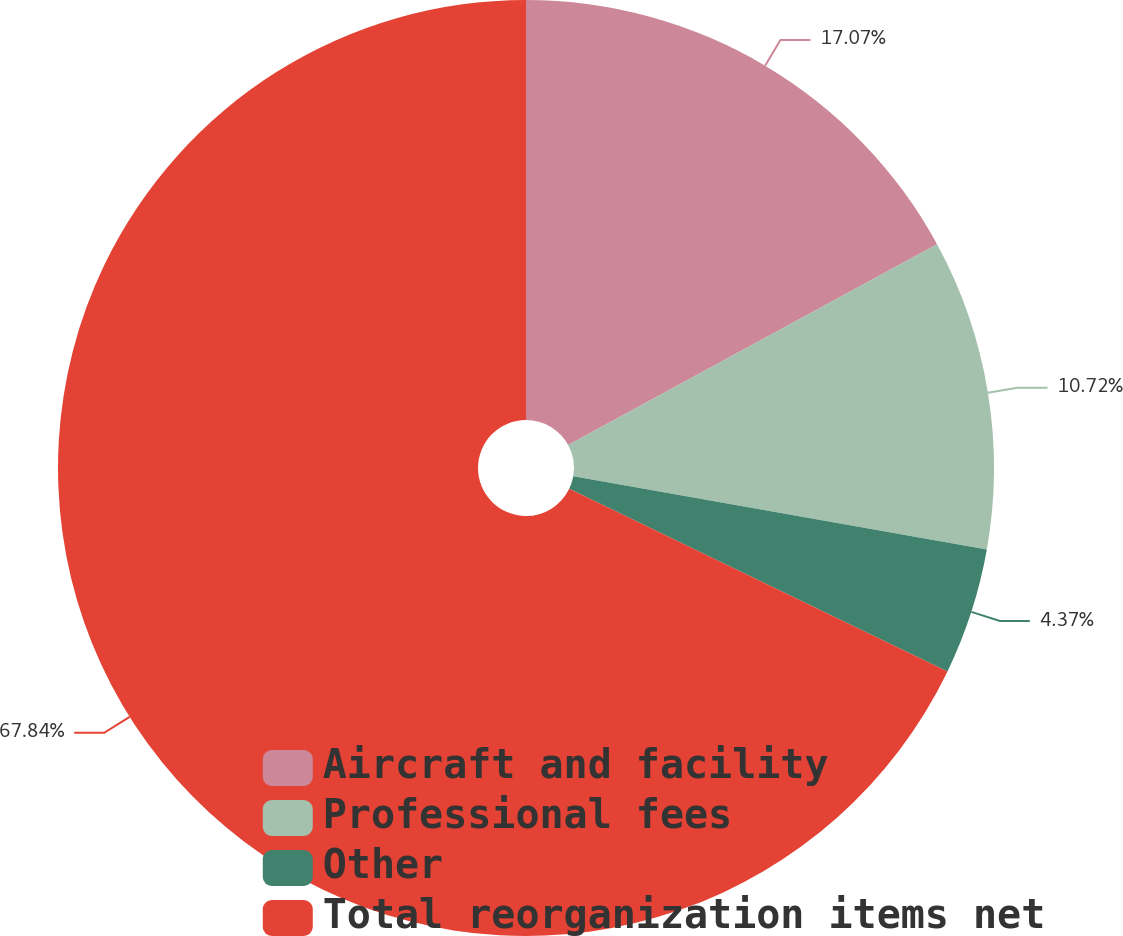<chart> <loc_0><loc_0><loc_500><loc_500><pie_chart><fcel>Aircraft and facility<fcel>Professional fees<fcel>Other<fcel>Total reorganization items net<nl><fcel>17.07%<fcel>10.72%<fcel>4.37%<fcel>67.85%<nl></chart> 